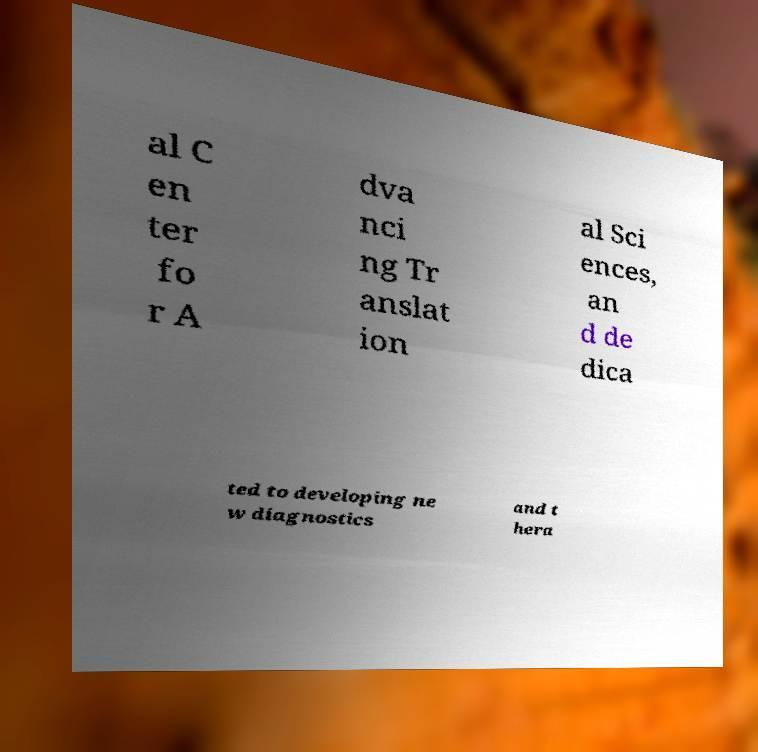Can you accurately transcribe the text from the provided image for me? al C en ter fo r A dva nci ng Tr anslat ion al Sci ences, an d de dica ted to developing ne w diagnostics and t hera 